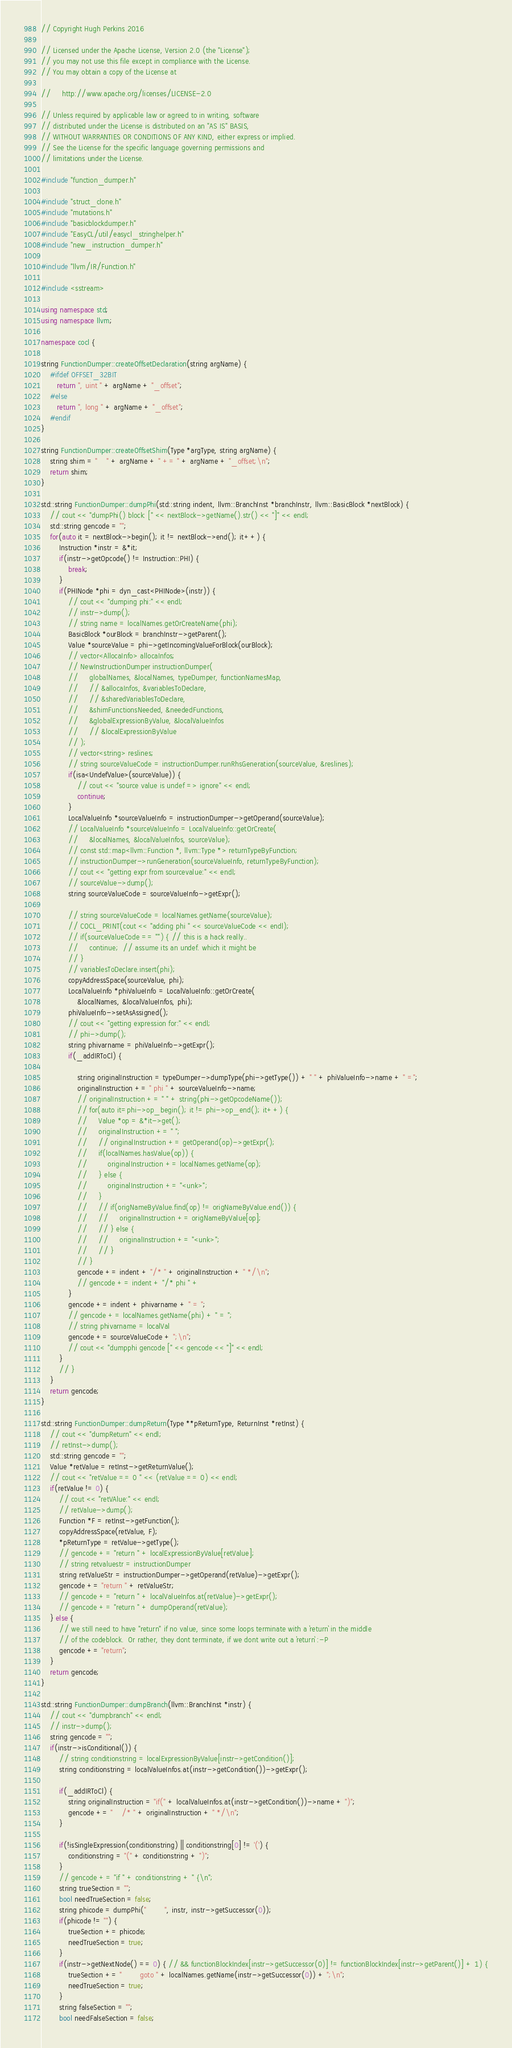Convert code to text. <code><loc_0><loc_0><loc_500><loc_500><_C++_>// Copyright Hugh Perkins 2016

// Licensed under the Apache License, Version 2.0 (the "License");
// you may not use this file except in compliance with the License.
// You may obtain a copy of the License at

//     http://www.apache.org/licenses/LICENSE-2.0

// Unless required by applicable law or agreed to in writing, software
// distributed under the License is distributed on an "AS IS" BASIS,
// WITHOUT WARRANTIES OR CONDITIONS OF ANY KIND, either express or implied.
// See the License for the specific language governing permissions and
// limitations under the License.

#include "function_dumper.h"

#include "struct_clone.h"
#include "mutations.h"
#include "basicblockdumper.h"
#include "EasyCL/util/easycl_stringhelper.h"
#include "new_instruction_dumper.h"

#include "llvm/IR/Function.h"

#include <sstream>

using namespace std;
using namespace llvm;

namespace cocl {

string FunctionDumper::createOffsetDeclaration(string argName) {
    #ifdef OFFSET_32BIT
       return ", uint " + argName + "_offset";
    #else
       return ", long " + argName + "_offset";
    #endif
}

string FunctionDumper::createOffsetShim(Type *argType, string argName) {
    string shim = "    " + argName + " += " + argName + "_offset;\n";
    return shim;
}

std::string FunctionDumper::dumpPhi(std::string indent, llvm::BranchInst *branchInstr, llvm::BasicBlock *nextBlock) {
    // cout << "dumpPhi() block: [" << nextBlock->getName().str() << "]" << endl;
    std::string gencode = "";
    for(auto it = nextBlock->begin(); it != nextBlock->end(); it++) {
        Instruction *instr = &*it;
        if(instr->getOpcode() != Instruction::PHI) {
            break;
        }
        if(PHINode *phi = dyn_cast<PHINode>(instr)) {
            // cout << "dumping phi:" << endl;
            // instr->dump();
            // string name = localNames.getOrCreateName(phi);
            BasicBlock *ourBlock = branchInstr->getParent();
            Value *sourceValue = phi->getIncomingValueForBlock(ourBlock);
            // vector<AllocaInfo> allocaInfos;
            // NewInstructionDumper instructionDumper(
            //     globalNames, &localNames, typeDumper, functionNamesMap,
            //     // &allocaInfos, &variablesToDeclare,
            //     // &sharedVariablesToDeclare,
            //     &shimFunctionsNeeded, &neededFunctions,
            //     &globalExpressionByValue, &localValueInfos
            //     // &localExpressionByValue
            // );
            // vector<string> reslines;
            // string sourceValueCode = instructionDumper.runRhsGeneration(sourceValue, &reslines);
            if(isa<UndefValue>(sourceValue)) {
                // cout << "source value is undef => ignore" << endl;
                continue;
            }
            LocalValueInfo *sourceValueInfo = instructionDumper->getOperand(sourceValue);
            // LocalValueInfo *sourceValueInfo = LocalValueInfo::getOrCreate(
            //     &localNames, &localValueInfos, sourceValue);
            // const std::map<llvm::Function *, llvm::Type *> returnTypeByFunction;
            // instructionDumper->runGeneration(sourceValueInfo, returnTypeByFunction);
            // cout << "getting expr from sourcevalue:" << endl;
            // sourceValue->dump();
            string sourceValueCode = sourceValueInfo->getExpr();

            // string sourceValueCode = localNames.getName(sourceValue);
            // COCL_PRINT(cout << "adding phi " << sourceValueCode << endl);
            // if(sourceValueCode == "") { // this is a hack really..
            //     continue;  // assume its an undef. which it might be
            // }
            // variablesToDeclare.insert(phi);
            copyAddressSpace(sourceValue, phi);
            LocalValueInfo *phiValueInfo = LocalValueInfo::getOrCreate(
                &localNames, &localValueInfos, phi);
            phiValueInfo->setAsAssigned();
            // cout << "getting expression for:" << endl;
            // phi->dump();
            string phivarname = phiValueInfo->getExpr();
            if(_addIRToCl) {

                string originalInstruction = typeDumper->dumpType(phi->getType()) + " " + phiValueInfo->name + " =";
                originalInstruction += " phi " + sourceValueInfo->name;
                // originalInstruction += " " + string(phi->getOpcodeName());
                // for(auto it=phi->op_begin(); it != phi->op_end(); it++) {
                //     Value *op = &*it->get();
                //     originalInstruction += " ";
                //     // originalInstruction += getOperand(op)->getExpr();
                //     if(localNames.hasValue(op)) {
                //         originalInstruction += localNames.getName(op);
                //     } else {
                //         originalInstruction += "<unk>";
                //     }
                //     // if(origNameByValue.find(op) != origNameByValue.end()) {
                //     //     originalInstruction += origNameByValue[op];
                //     // } else {
                //     //     originalInstruction += "<unk>";
                //     // }
                // }
                gencode += indent + "/* " + originalInstruction + " */\n";
                // gencode += indent + "/* phi " + 
            }
            gencode += indent + phivarname + " = ";
            // gencode += localNames.getName(phi) + " = ";
            // string phivarname = localVal
            gencode += sourceValueCode + ";\n";
            // cout << "dumpphi gencode [" << gencode << "]" << endl;
        }
        // }
    }
    return gencode;
}

std::string FunctionDumper::dumpReturn(Type **pReturnType, ReturnInst *retInst) {
    // cout << "dumpReturn" << endl;
    // retInst->dump();
    std::string gencode = "";
    Value *retValue = retInst->getReturnValue();
    // cout << "retValue == 0 " << (retValue == 0) << endl;
    if(retValue != 0) {
        // cout << "retVAlue:" << endl;
        // retValue->dump();
        Function *F = retInst->getFunction();
        copyAddressSpace(retValue, F);
        *pReturnType = retValue->getType();
        // gencode += "return " + localExpressionByValue[retValue];
        // string retvaluestr = instructionDumper
        string retValueStr = instructionDumper->getOperand(retValue)->getExpr();
        gencode += "return " + retValueStr;
        // gencode += "return " + localValueInfos.at(retValue)->getExpr();
        // gencode += "return " + dumpOperand(retValue);
    } else {
        // we still need to have "return" if no value, since some loops terminate with a `return` in the middle
        // of the codeblock.  Or rather, they dont terminate, if we dont write out a `return` :-P
        gencode += "return";
    }
    return gencode;
}

std::string FunctionDumper::dumpBranch(llvm::BranchInst *instr) {
    // cout << "dumpbranch" << endl;
    // instr->dump();
    string gencode = "";
    if(instr->isConditional()) {
        // string conditionstring = localExpressionByValue[instr->getCondition()];
        string conditionstring = localValueInfos.at(instr->getCondition())->getExpr();

        if(_addIRToCl) {
            string originalInstruction = "if(" + localValueInfos.at(instr->getCondition())->name + ")";
            gencode += "    /* " + originalInstruction + " */\n";
        }

        if(!isSingleExpression(conditionstring) || conditionstring[0] != '(') {
            conditionstring = "(" + conditionstring + ")";
        }
        // gencode += "if " + conditionstring + " {\n";
        string trueSection = "";
        bool needTrueSection = false;
        string phicode = dumpPhi("        ", instr, instr->getSuccessor(0));
        if(phicode != "") {
            trueSection += phicode;
            needTrueSection = true;
        }
        if(instr->getNextNode() == 0) { // && functionBlockIndex[instr->getSuccessor(0)] != functionBlockIndex[instr->getParent()] + 1) {
            trueSection += "        goto " + localNames.getName(instr->getSuccessor(0)) + ";\n";
            needTrueSection = true;
        }
        string falseSection = "";
        bool needFalseSection = false;</code> 